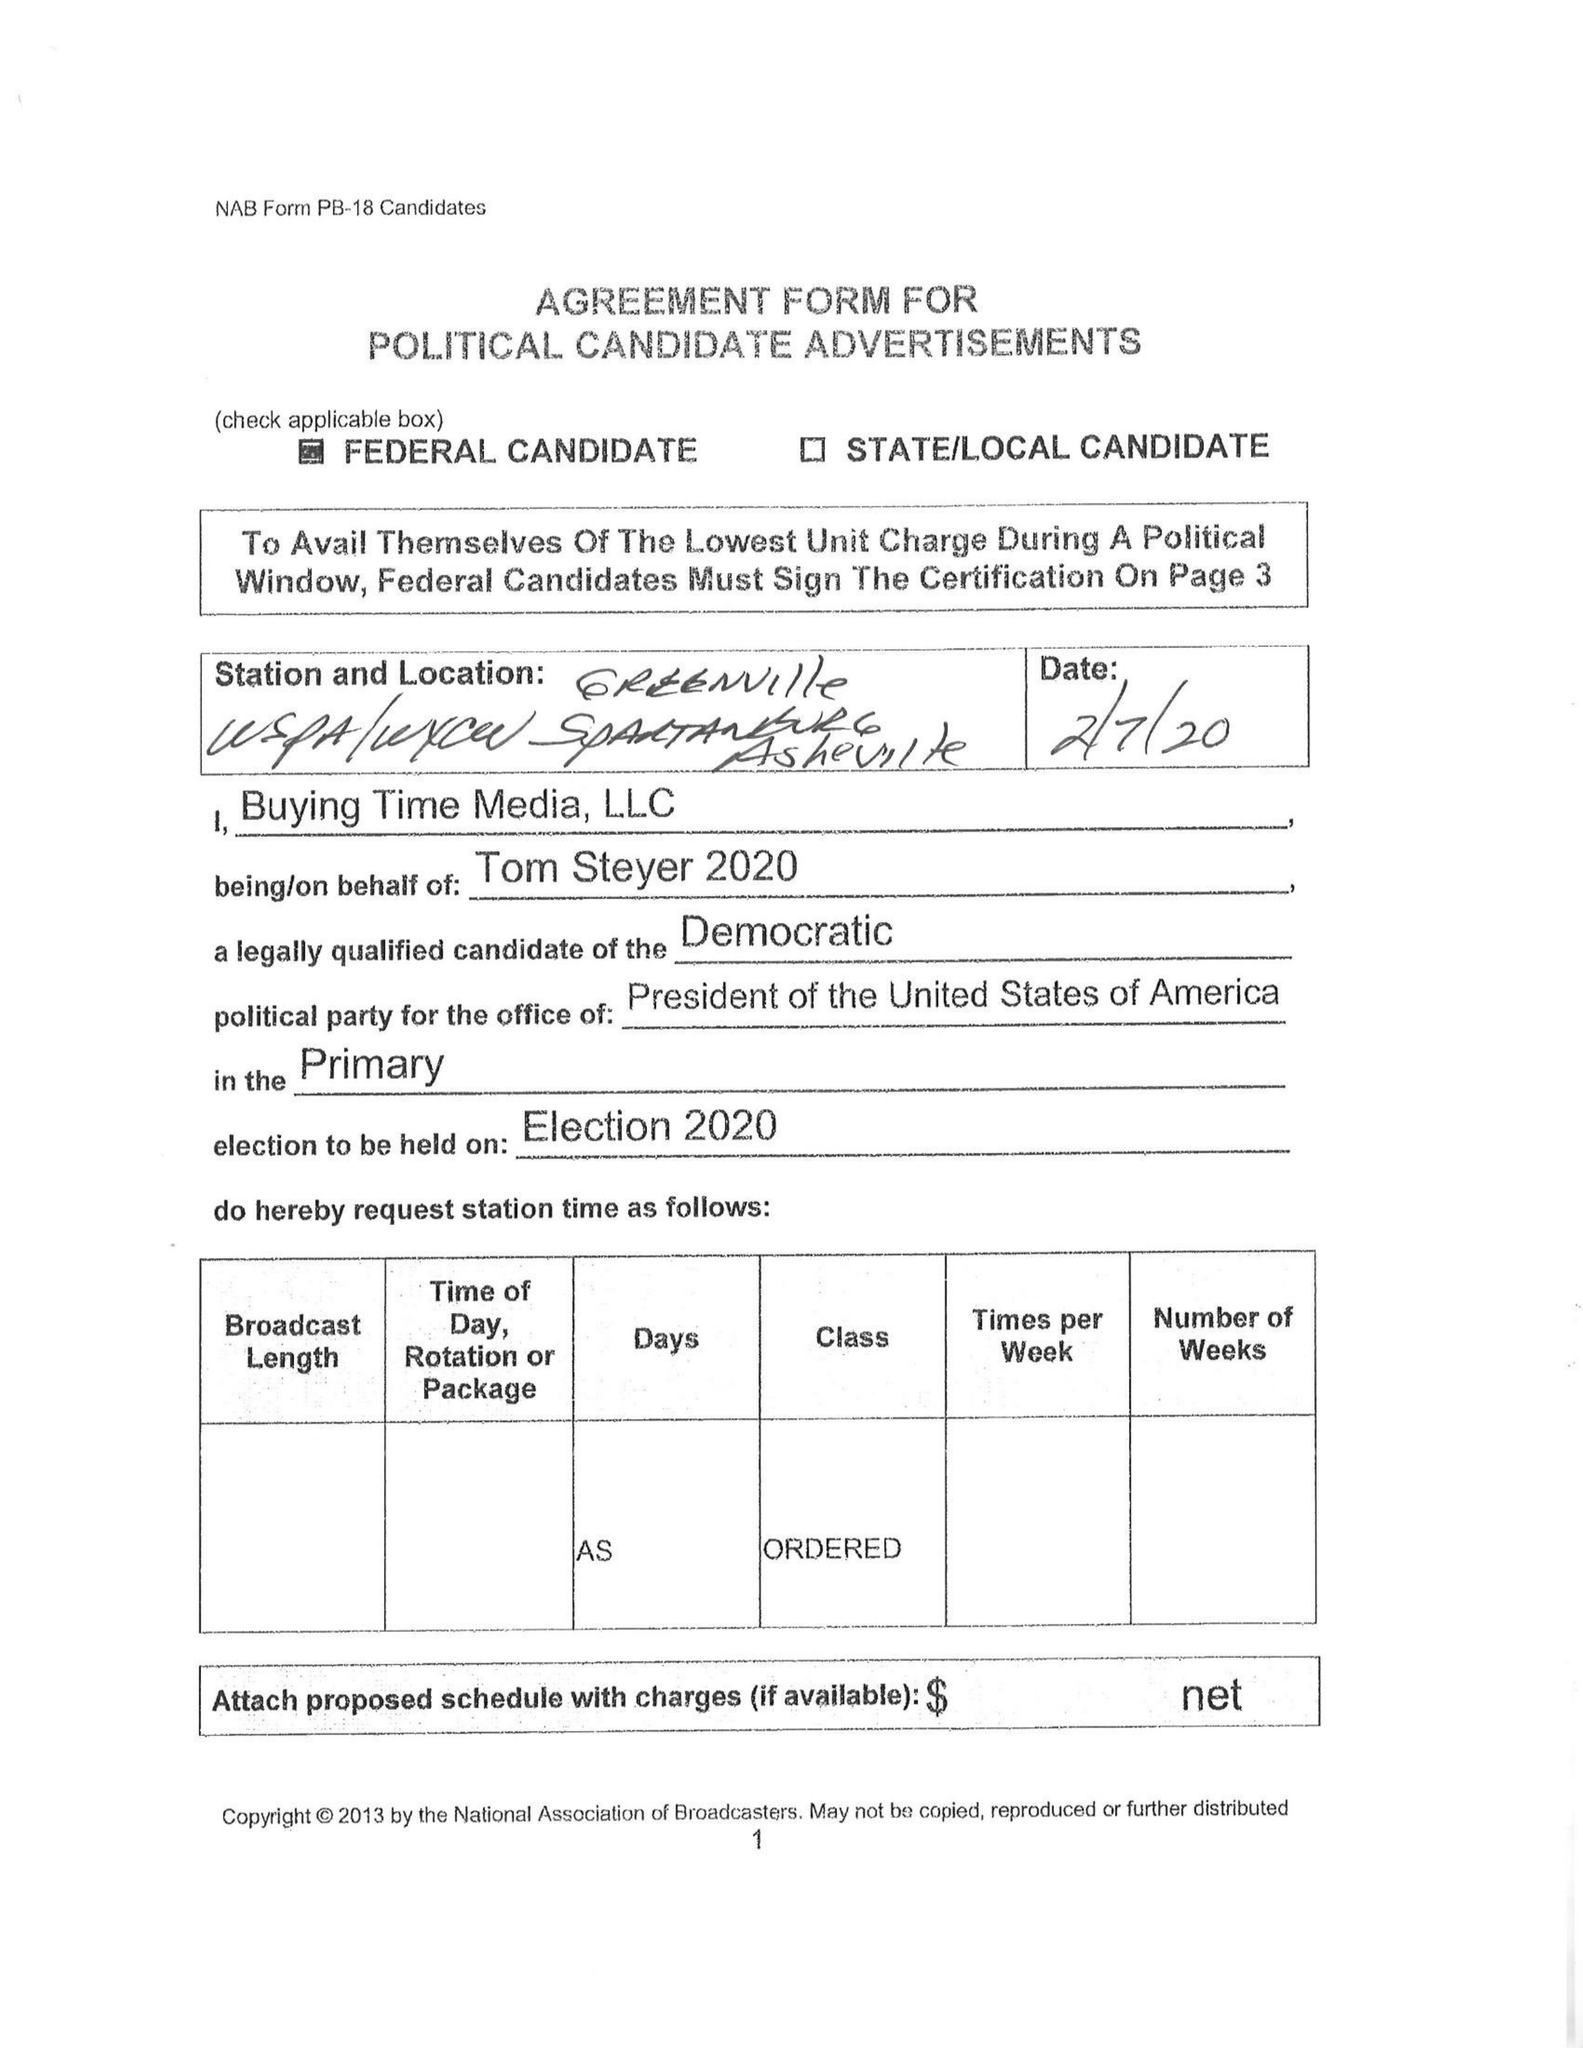What is the value for the gross_amount?
Answer the question using a single word or phrase. None 